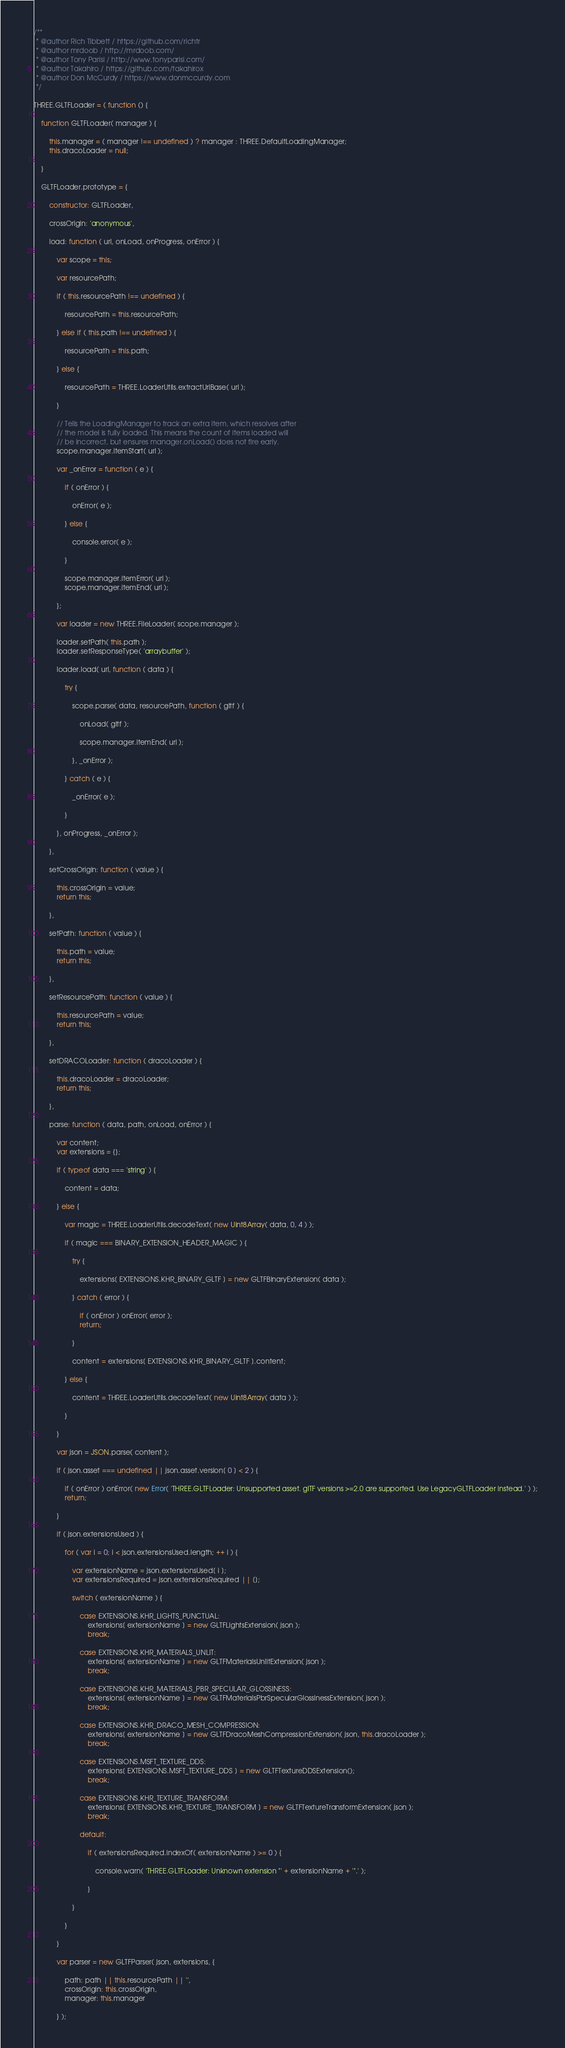Convert code to text. <code><loc_0><loc_0><loc_500><loc_500><_JavaScript_>/**
 * @author Rich Tibbett / https://github.com/richtr
 * @author mrdoob / http://mrdoob.com/
 * @author Tony Parisi / http://www.tonyparisi.com/
 * @author Takahiro / https://github.com/takahirox
 * @author Don McCurdy / https://www.donmccurdy.com
 */

THREE.GLTFLoader = ( function () {

	function GLTFLoader( manager ) {

		this.manager = ( manager !== undefined ) ? manager : THREE.DefaultLoadingManager;
		this.dracoLoader = null;

	}

	GLTFLoader.prototype = {

		constructor: GLTFLoader,

		crossOrigin: 'anonymous',

		load: function ( url, onLoad, onProgress, onError ) {

			var scope = this;

			var resourcePath;

			if ( this.resourcePath !== undefined ) {

				resourcePath = this.resourcePath;

			} else if ( this.path !== undefined ) {

				resourcePath = this.path;

			} else {

				resourcePath = THREE.LoaderUtils.extractUrlBase( url );

			}

			// Tells the LoadingManager to track an extra item, which resolves after
			// the model is fully loaded. This means the count of items loaded will
			// be incorrect, but ensures manager.onLoad() does not fire early.
			scope.manager.itemStart( url );

			var _onError = function ( e ) {

				if ( onError ) {

					onError( e );

				} else {

					console.error( e );

				}

				scope.manager.itemError( url );
				scope.manager.itemEnd( url );

			};

			var loader = new THREE.FileLoader( scope.manager );

			loader.setPath( this.path );
			loader.setResponseType( 'arraybuffer' );

			loader.load( url, function ( data ) {

				try {

					scope.parse( data, resourcePath, function ( gltf ) {

						onLoad( gltf );

						scope.manager.itemEnd( url );

					}, _onError );

				} catch ( e ) {

					_onError( e );

				}

			}, onProgress, _onError );

		},

		setCrossOrigin: function ( value ) {

			this.crossOrigin = value;
			return this;

		},

		setPath: function ( value ) {

			this.path = value;
			return this;

		},

		setResourcePath: function ( value ) {

			this.resourcePath = value;
			return this;

		},

		setDRACOLoader: function ( dracoLoader ) {

			this.dracoLoader = dracoLoader;
			return this;

		},

		parse: function ( data, path, onLoad, onError ) {

			var content;
			var extensions = {};

			if ( typeof data === 'string' ) {

				content = data;

			} else {

				var magic = THREE.LoaderUtils.decodeText( new Uint8Array( data, 0, 4 ) );

				if ( magic === BINARY_EXTENSION_HEADER_MAGIC ) {

					try {

						extensions[ EXTENSIONS.KHR_BINARY_GLTF ] = new GLTFBinaryExtension( data );

					} catch ( error ) {

						if ( onError ) onError( error );
						return;

					}

					content = extensions[ EXTENSIONS.KHR_BINARY_GLTF ].content;

				} else {

					content = THREE.LoaderUtils.decodeText( new Uint8Array( data ) );

				}

			}

			var json = JSON.parse( content );

			if ( json.asset === undefined || json.asset.version[ 0 ] < 2 ) {

				if ( onError ) onError( new Error( 'THREE.GLTFLoader: Unsupported asset. glTF versions >=2.0 are supported. Use LegacyGLTFLoader instead.' ) );
				return;

			}

			if ( json.extensionsUsed ) {

				for ( var i = 0; i < json.extensionsUsed.length; ++ i ) {

					var extensionName = json.extensionsUsed[ i ];
					var extensionsRequired = json.extensionsRequired || [];

					switch ( extensionName ) {

						case EXTENSIONS.KHR_LIGHTS_PUNCTUAL:
							extensions[ extensionName ] = new GLTFLightsExtension( json );
							break;

						case EXTENSIONS.KHR_MATERIALS_UNLIT:
							extensions[ extensionName ] = new GLTFMaterialsUnlitExtension( json );
							break;

						case EXTENSIONS.KHR_MATERIALS_PBR_SPECULAR_GLOSSINESS:
							extensions[ extensionName ] = new GLTFMaterialsPbrSpecularGlossinessExtension( json );
							break;

						case EXTENSIONS.KHR_DRACO_MESH_COMPRESSION:
							extensions[ extensionName ] = new GLTFDracoMeshCompressionExtension( json, this.dracoLoader );
							break;

						case EXTENSIONS.MSFT_TEXTURE_DDS:
							extensions[ EXTENSIONS.MSFT_TEXTURE_DDS ] = new GLTFTextureDDSExtension();
							break;

						case EXTENSIONS.KHR_TEXTURE_TRANSFORM:
							extensions[ EXTENSIONS.KHR_TEXTURE_TRANSFORM ] = new GLTFTextureTransformExtension( json );
							break;

						default:

							if ( extensionsRequired.indexOf( extensionName ) >= 0 ) {

								console.warn( 'THREE.GLTFLoader: Unknown extension "' + extensionName + '".' );

							}

					}

				}

			}

			var parser = new GLTFParser( json, extensions, {

				path: path || this.resourcePath || '',
				crossOrigin: this.crossOrigin,
				manager: this.manager

			} );
</code> 